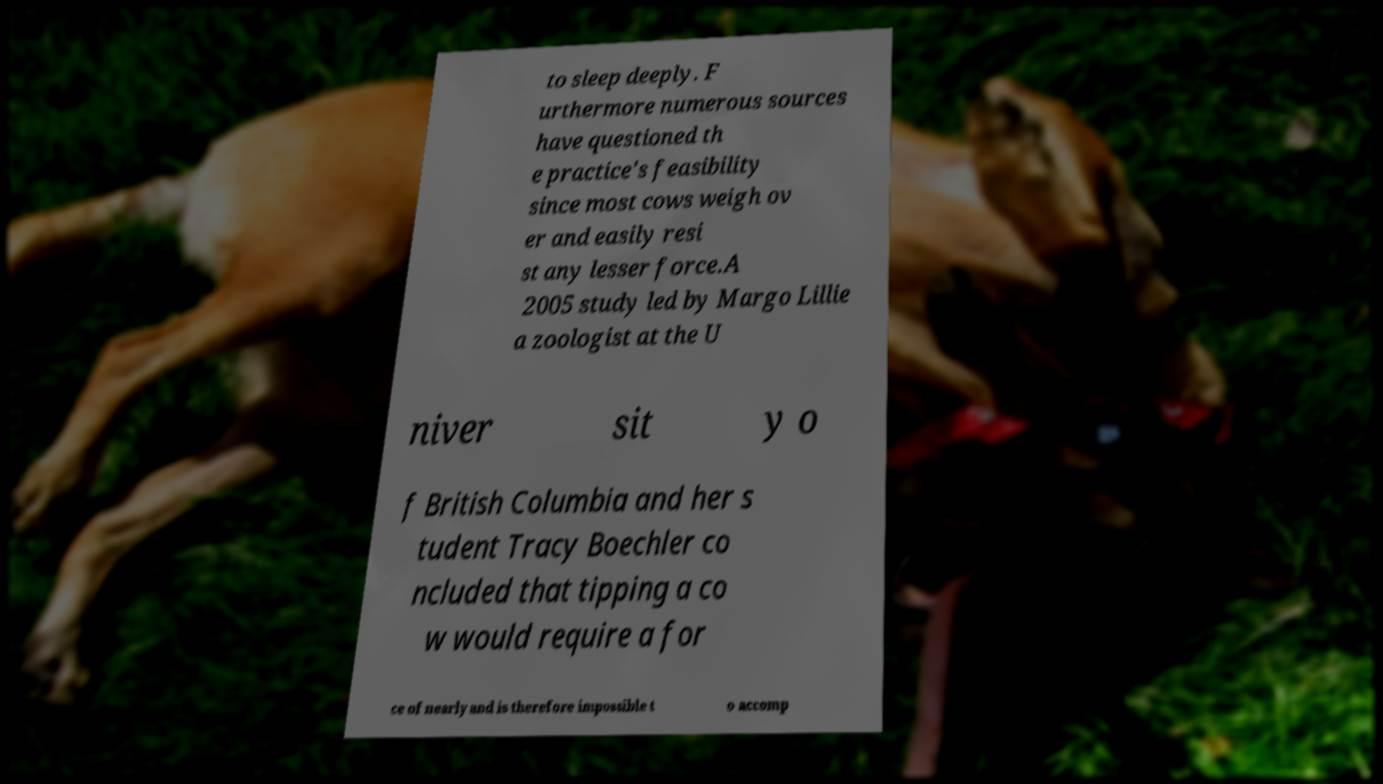Could you assist in decoding the text presented in this image and type it out clearly? to sleep deeply. F urthermore numerous sources have questioned th e practice's feasibility since most cows weigh ov er and easily resi st any lesser force.A 2005 study led by Margo Lillie a zoologist at the U niver sit y o f British Columbia and her s tudent Tracy Boechler co ncluded that tipping a co w would require a for ce of nearly and is therefore impossible t o accomp 